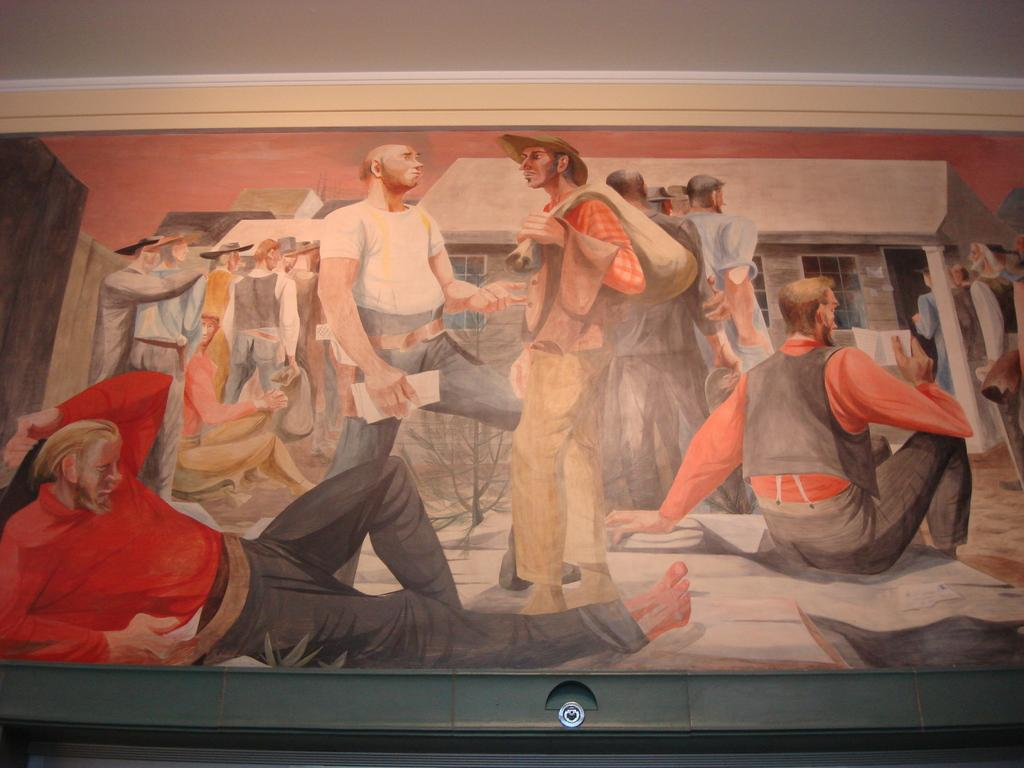What is the main subject of the painting? The painting depicts a group of people. Can you describe the positions of the people in the painting? Some people are standing, while others are sitting, and there is a man lying on the ground. What type of structure is visible in the painting? There is a house with windows in the painting. What type of lamp is hanging from the root of the tree in the painting? There is no lamp or tree present in the painting; it features a group of people and a house with windows. 